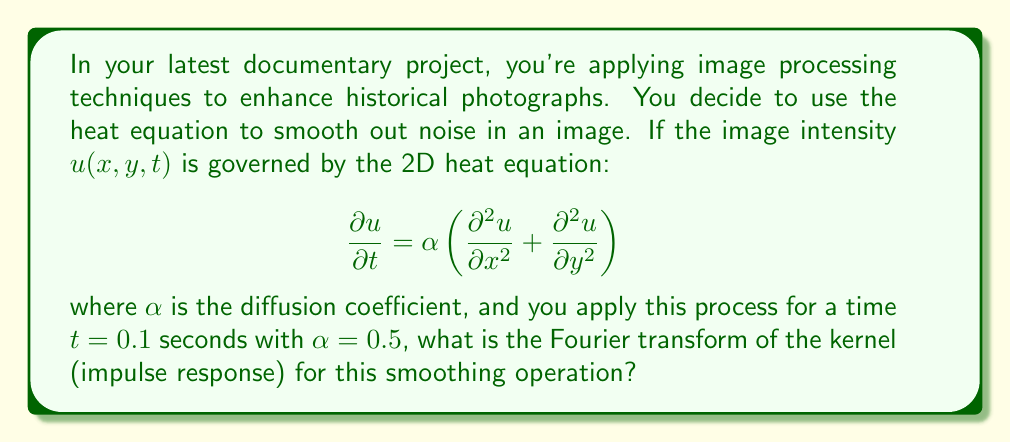Can you answer this question? To solve this problem, we'll follow these steps:

1) The heat equation in 2D can be solved using Fourier transforms. The solution in the frequency domain is:

   $$\hat{u}(\omega_x, \omega_y, t) = \hat{u}(\omega_x, \omega_y, 0) \cdot e^{-\alpha (\omega_x^2 + \omega_y^2) t}$$

   where $\hat{u}$ denotes the Fourier transform of $u$, and $\omega_x, \omega_y$ are the spatial frequencies.

2) The term $e^{-\alpha (\omega_x^2 + \omega_y^2) t}$ is the Fourier transform of the kernel (impulse response) of the heat equation.

3) In our case, $\alpha = 0.5$ and $t = 0.1$, so the kernel in the frequency domain is:

   $$H(\omega_x, \omega_y) = e^{-0.5 \cdot 0.1 \cdot (\omega_x^2 + \omega_y^2)} = e^{-0.05 (\omega_x^2 + \omega_y^2)}$$

4) This is the Fourier transform of a 2D Gaussian function. The inverse Fourier transform of this gives us the spatial domain kernel:

   $$h(x,y) = \frac{1}{4\pi \alpha t} e^{-\frac{x^2 + y^2}{4\alpha t}}$$

5) Substituting our values:

   $$h(x,y) = \frac{1}{4\pi \cdot 0.5 \cdot 0.1} e^{-\frac{x^2 + y^2}{4 \cdot 0.5 \cdot 0.1}} = \frac{5}{\pi} e^{-10(x^2 + y^2)}$$

This Gaussian kernel in the spatial domain corresponds to the frequency domain kernel we found in step 3.
Answer: The Fourier transform of the kernel for this smoothing operation is:

$$H(\omega_x, \omega_y) = e^{-0.05 (\omega_x^2 + \omega_y^2)}$$ 